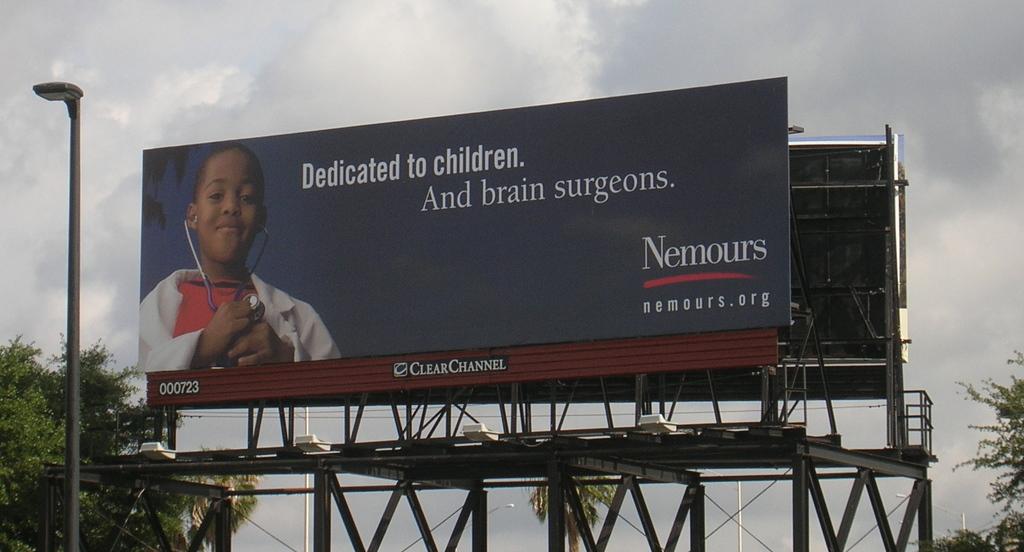What number is on the bottom left of the billboard?
Offer a very short reply. 000723. What website is being advertised?
Offer a terse response. Nemours.org. 